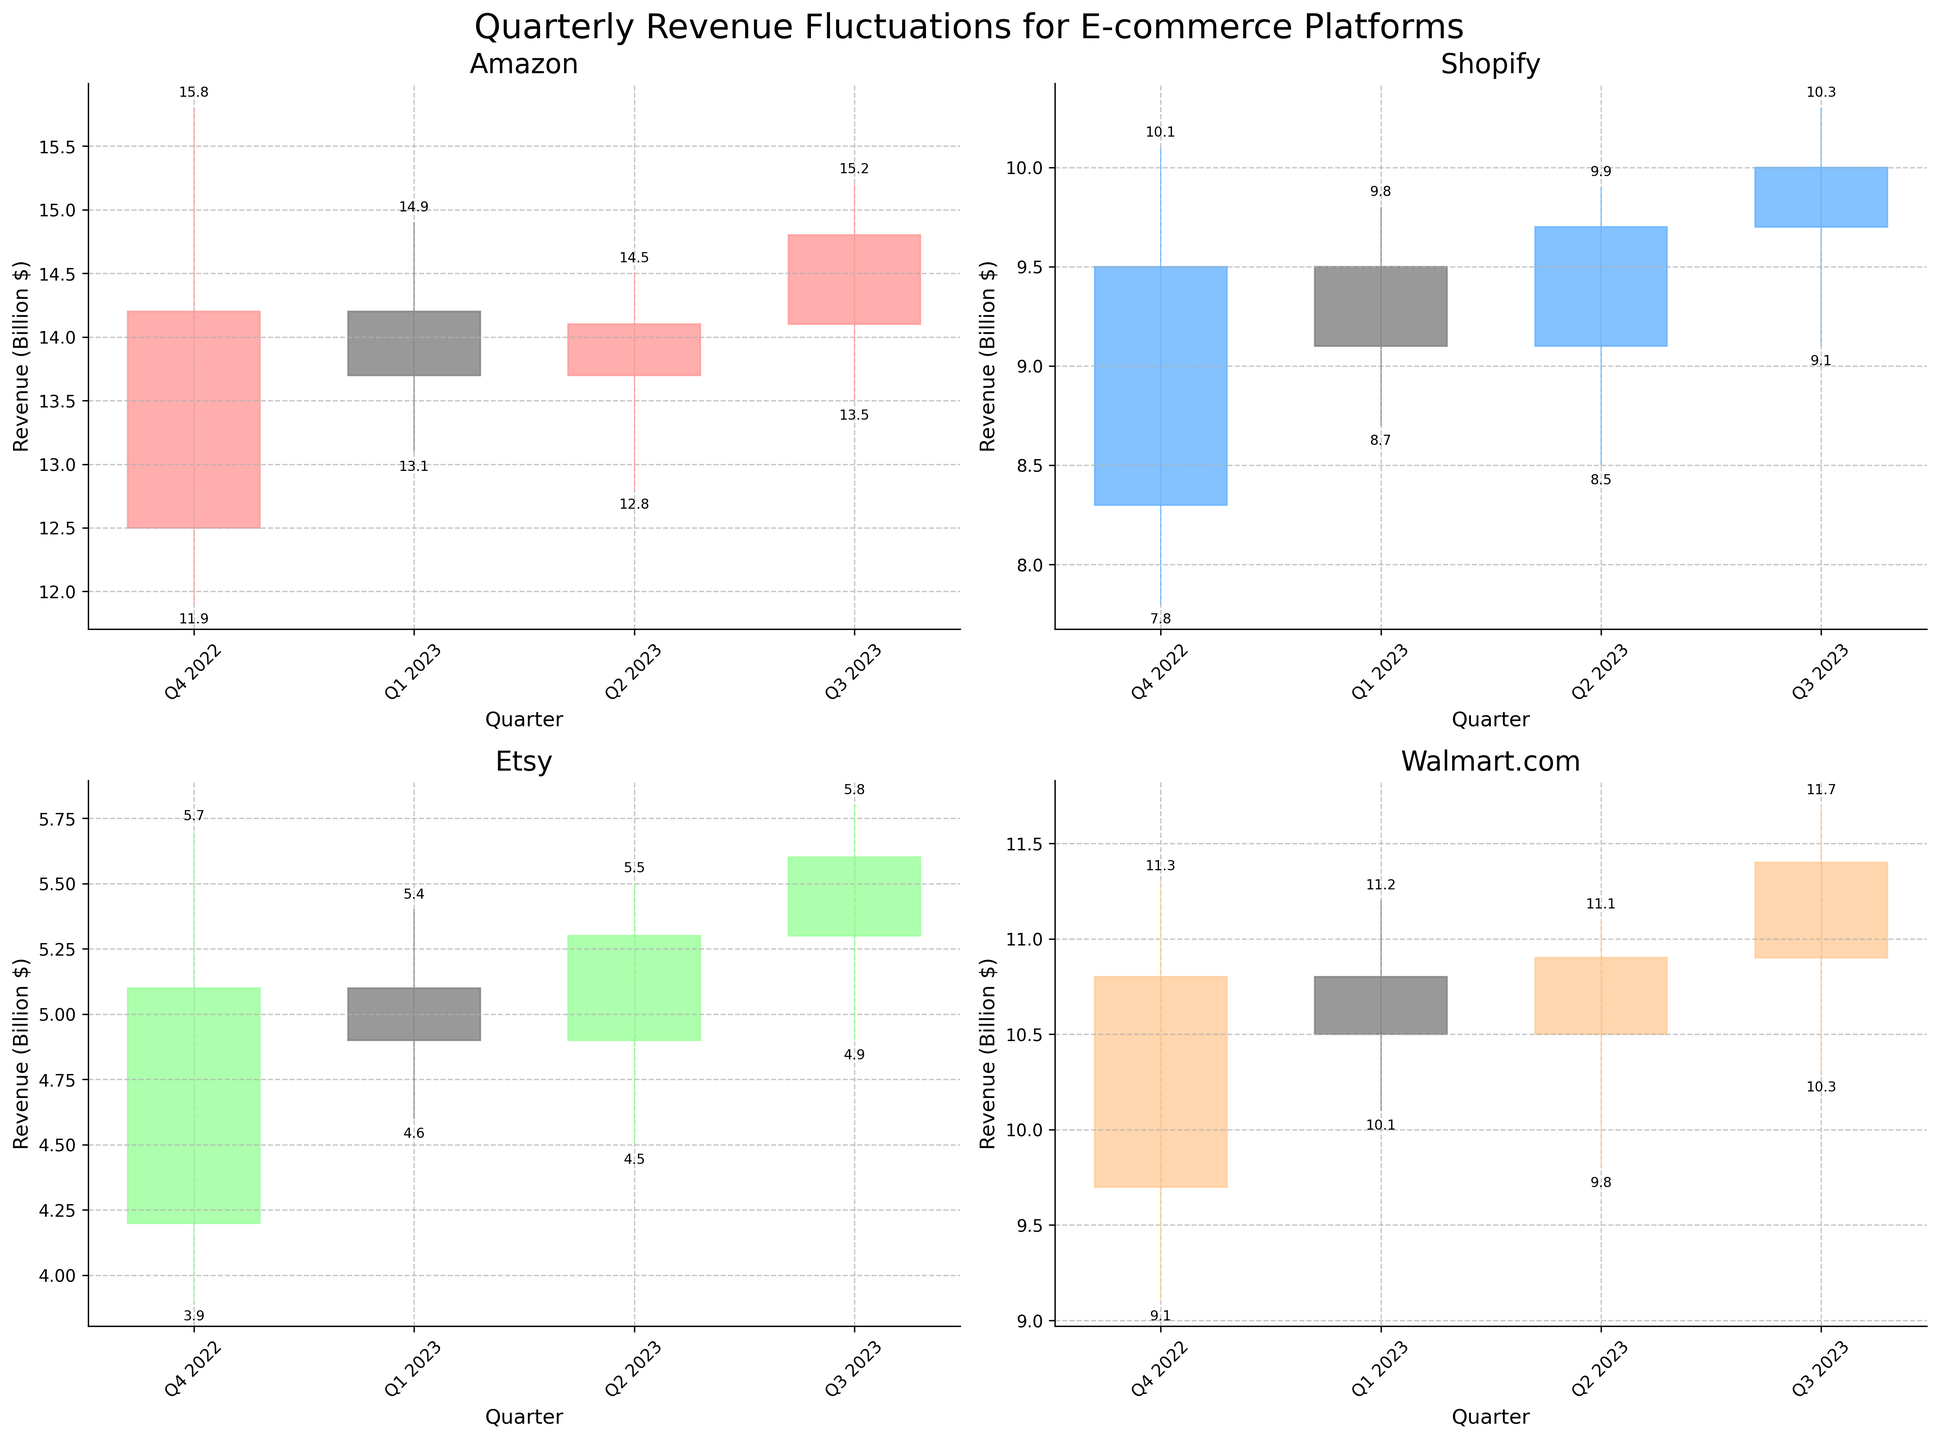Which platform showed the highest revenue in Q4 2022? The highest revenue in Q4 2022 is represented by the highest 'High' value. According to the plot, Amazon had the highest revenue in Q4 2022 with a 'High' value of 15.8 billion dollars.
Answer: Amazon Which e-commerce platform had the lowest closing revenue in Q1 2023? To find the lowest closing revenue in Q1 2023, we look at the 'Close' value for each platform in that quarter. Etsy had the lowest closing revenue with a 'Close' value of 4.9 billion dollars.
Answer: Etsy What was the difference between the highest and lowest revenue for Shopify in Q4 2022? To find the difference, subtract the 'Low' value from the 'High' value for Shopify in Q4 2022. The 'High' value is 10.1 billion dollars, and the 'Low' value is 7.8 billion dollars. Thus, the difference is 10.1 - 7.8 = 2.3 billion dollars.
Answer: 2.3 billion dollars Which platform saw a decrease in revenue from Q4 2022 to Q1 2023? To see which platforms had a decrease, compare the 'Close' values of Q4 2022 and Q1 2023. Amazon (14.2 to 13.7), Shopify (9.5 to 9.1), and Etsy (5.1 to 4.9) all saw decreases in revenue, while Walmart.com did not.
Answer: Amazon, Shopify, Etsy Did any platform's revenue exceed 15 billion dollars in any quarter? To determine if any platform's revenue exceeded 15 billion dollars, check the 'High' values across all quarters. None of the 'High' values exceed 15 billion dollars; Amazon had the highest at 15.8 billion dollars in Q4 2022, which is close but exceeds 15.0.
Answer: No Which platform had the most consistent revenue across all quarters? Consistency can be evaluated by examining the magnitude of fluctuations within the 'High' and 'Low' values across quarters. Walmart.com exhibits less fluctuation in the 'High' and 'Low' values compared to other platforms, indicating more consistent revenues.
Answer: Walmart.com How did Etsy's revenue change from Q3 2023 to Q2 2023? To observe the change, compare the 'Close' values of Q3 2023 and Q2 2023 for Etsy. In Q2 2023, the 'Close' value was 5.3 billion, and in Q3 2023, it was 5.6 billion. Hence, Etsy's revenue increased from 5.3 to 5.6 billion dollars.
Answer: Increased by 0.3 billion dollars Which platform had the highest revenue in Q3 2023, and what was the revenue value? The highest revenue for any platform in Q3 2023 is represented by the highest 'High' value. For Q3 2023, Amazon had the highest revenue with a 'High' value of 15.2 billion dollars.
Answer: Amazon, 15.2 billion dollars 